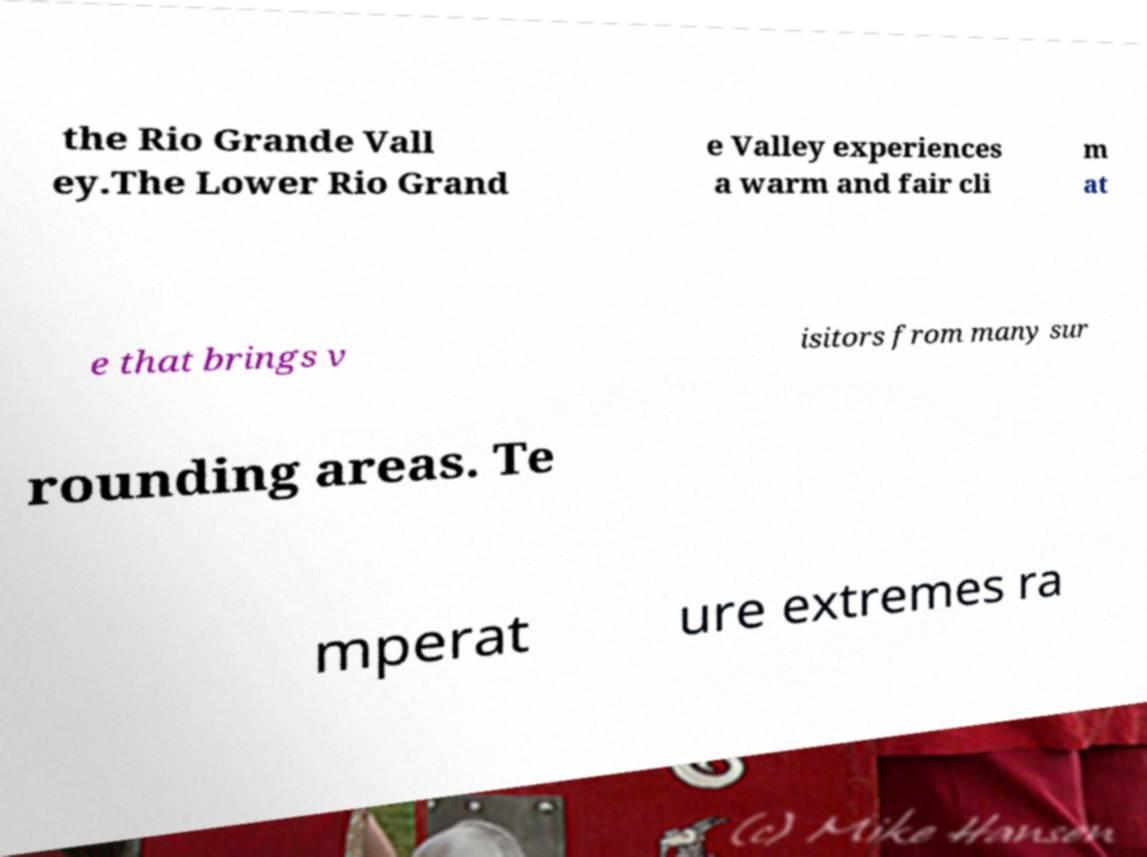Could you assist in decoding the text presented in this image and type it out clearly? the Rio Grande Vall ey.The Lower Rio Grand e Valley experiences a warm and fair cli m at e that brings v isitors from many sur rounding areas. Te mperat ure extremes ra 